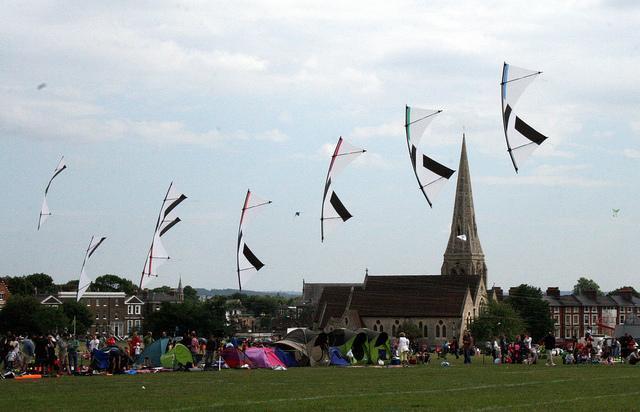What might be taking place in the building to the right?
Answer the question by selecting the correct answer among the 4 following choices.
Options: Baseball game, roller derby, worship service, property auction. Worship service. 